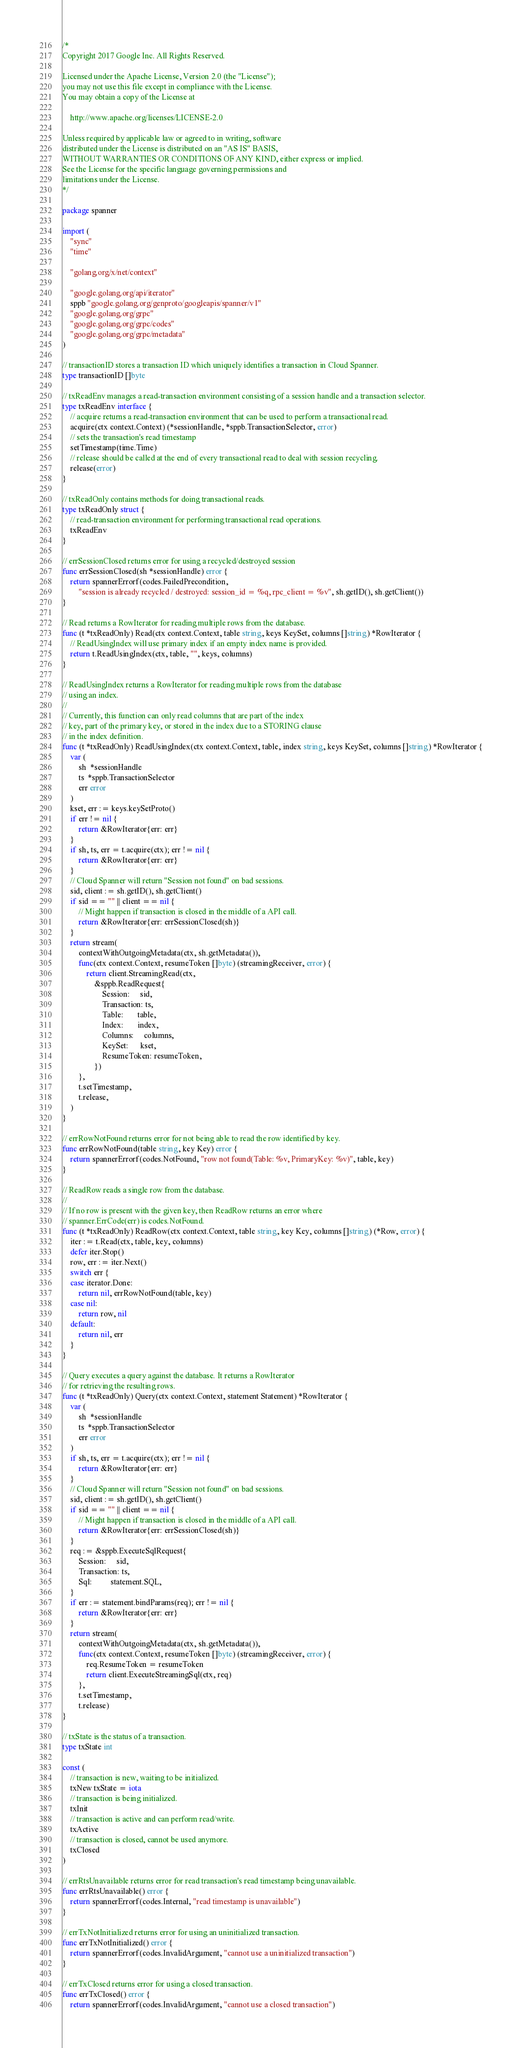<code> <loc_0><loc_0><loc_500><loc_500><_Go_>/*
Copyright 2017 Google Inc. All Rights Reserved.

Licensed under the Apache License, Version 2.0 (the "License");
you may not use this file except in compliance with the License.
You may obtain a copy of the License at

    http://www.apache.org/licenses/LICENSE-2.0

Unless required by applicable law or agreed to in writing, software
distributed under the License is distributed on an "AS IS" BASIS,
WITHOUT WARRANTIES OR CONDITIONS OF ANY KIND, either express or implied.
See the License for the specific language governing permissions and
limitations under the License.
*/

package spanner

import (
	"sync"
	"time"

	"golang.org/x/net/context"

	"google.golang.org/api/iterator"
	sppb "google.golang.org/genproto/googleapis/spanner/v1"
	"google.golang.org/grpc"
	"google.golang.org/grpc/codes"
	"google.golang.org/grpc/metadata"
)

// transactionID stores a transaction ID which uniquely identifies a transaction in Cloud Spanner.
type transactionID []byte

// txReadEnv manages a read-transaction environment consisting of a session handle and a transaction selector.
type txReadEnv interface {
	// acquire returns a read-transaction environment that can be used to perform a transactional read.
	acquire(ctx context.Context) (*sessionHandle, *sppb.TransactionSelector, error)
	// sets the transaction's read timestamp
	setTimestamp(time.Time)
	// release should be called at the end of every transactional read to deal with session recycling.
	release(error)
}

// txReadOnly contains methods for doing transactional reads.
type txReadOnly struct {
	// read-transaction environment for performing transactional read operations.
	txReadEnv
}

// errSessionClosed returns error for using a recycled/destroyed session
func errSessionClosed(sh *sessionHandle) error {
	return spannerErrorf(codes.FailedPrecondition,
		"session is already recycled / destroyed: session_id = %q, rpc_client = %v", sh.getID(), sh.getClient())
}

// Read returns a RowIterator for reading multiple rows from the database.
func (t *txReadOnly) Read(ctx context.Context, table string, keys KeySet, columns []string) *RowIterator {
	// ReadUsingIndex will use primary index if an empty index name is provided.
	return t.ReadUsingIndex(ctx, table, "", keys, columns)
}

// ReadUsingIndex returns a RowIterator for reading multiple rows from the database
// using an index.
//
// Currently, this function can only read columns that are part of the index
// key, part of the primary key, or stored in the index due to a STORING clause
// in the index definition.
func (t *txReadOnly) ReadUsingIndex(ctx context.Context, table, index string, keys KeySet, columns []string) *RowIterator {
	var (
		sh  *sessionHandle
		ts  *sppb.TransactionSelector
		err error
	)
	kset, err := keys.keySetProto()
	if err != nil {
		return &RowIterator{err: err}
	}
	if sh, ts, err = t.acquire(ctx); err != nil {
		return &RowIterator{err: err}
	}
	// Cloud Spanner will return "Session not found" on bad sessions.
	sid, client := sh.getID(), sh.getClient()
	if sid == "" || client == nil {
		// Might happen if transaction is closed in the middle of a API call.
		return &RowIterator{err: errSessionClosed(sh)}
	}
	return stream(
		contextWithOutgoingMetadata(ctx, sh.getMetadata()),
		func(ctx context.Context, resumeToken []byte) (streamingReceiver, error) {
			return client.StreamingRead(ctx,
				&sppb.ReadRequest{
					Session:     sid,
					Transaction: ts,
					Table:       table,
					Index:       index,
					Columns:     columns,
					KeySet:      kset,
					ResumeToken: resumeToken,
				})
		},
		t.setTimestamp,
		t.release,
	)
}

// errRowNotFound returns error for not being able to read the row identified by key.
func errRowNotFound(table string, key Key) error {
	return spannerErrorf(codes.NotFound, "row not found(Table: %v, PrimaryKey: %v)", table, key)
}

// ReadRow reads a single row from the database.
//
// If no row is present with the given key, then ReadRow returns an error where
// spanner.ErrCode(err) is codes.NotFound.
func (t *txReadOnly) ReadRow(ctx context.Context, table string, key Key, columns []string) (*Row, error) {
	iter := t.Read(ctx, table, key, columns)
	defer iter.Stop()
	row, err := iter.Next()
	switch err {
	case iterator.Done:
		return nil, errRowNotFound(table, key)
	case nil:
		return row, nil
	default:
		return nil, err
	}
}

// Query executes a query against the database. It returns a RowIterator
// for retrieving the resulting rows.
func (t *txReadOnly) Query(ctx context.Context, statement Statement) *RowIterator {
	var (
		sh  *sessionHandle
		ts  *sppb.TransactionSelector
		err error
	)
	if sh, ts, err = t.acquire(ctx); err != nil {
		return &RowIterator{err: err}
	}
	// Cloud Spanner will return "Session not found" on bad sessions.
	sid, client := sh.getID(), sh.getClient()
	if sid == "" || client == nil {
		// Might happen if transaction is closed in the middle of a API call.
		return &RowIterator{err: errSessionClosed(sh)}
	}
	req := &sppb.ExecuteSqlRequest{
		Session:     sid,
		Transaction: ts,
		Sql:         statement.SQL,
	}
	if err := statement.bindParams(req); err != nil {
		return &RowIterator{err: err}
	}
	return stream(
		contextWithOutgoingMetadata(ctx, sh.getMetadata()),
		func(ctx context.Context, resumeToken []byte) (streamingReceiver, error) {
			req.ResumeToken = resumeToken
			return client.ExecuteStreamingSql(ctx, req)
		},
		t.setTimestamp,
		t.release)
}

// txState is the status of a transaction.
type txState int

const (
	// transaction is new, waiting to be initialized.
	txNew txState = iota
	// transaction is being initialized.
	txInit
	// transaction is active and can perform read/write.
	txActive
	// transaction is closed, cannot be used anymore.
	txClosed
)

// errRtsUnavailable returns error for read transaction's read timestamp being unavailable.
func errRtsUnavailable() error {
	return spannerErrorf(codes.Internal, "read timestamp is unavailable")
}

// errTxNotInitialized returns error for using an uninitialized transaction.
func errTxNotInitialized() error {
	return spannerErrorf(codes.InvalidArgument, "cannot use a uninitialized transaction")
}

// errTxClosed returns error for using a closed transaction.
func errTxClosed() error {
	return spannerErrorf(codes.InvalidArgument, "cannot use a closed transaction")</code> 